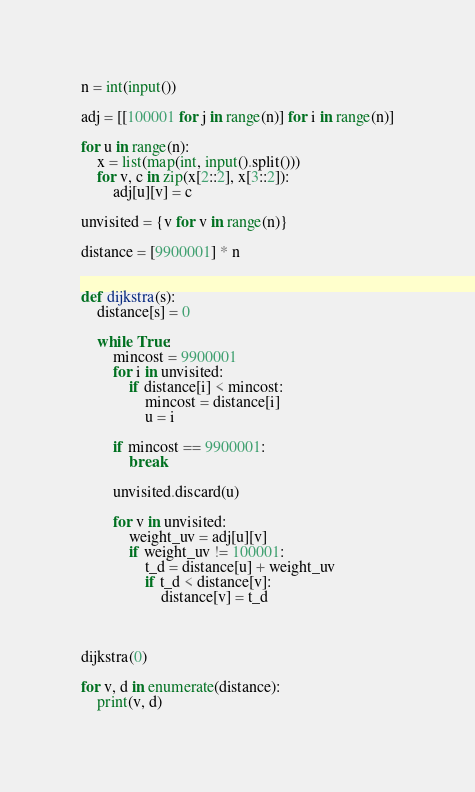Convert code to text. <code><loc_0><loc_0><loc_500><loc_500><_Python_>n = int(input())

adj = [[100001 for j in range(n)] for i in range(n)]

for u in range(n):
    x = list(map(int, input().split()))
    for v, c in zip(x[2::2], x[3::2]):
        adj[u][v] = c

unvisited = {v for v in range(n)}

distance = [9900001] * n


def dijkstra(s):
    distance[s] = 0

    while True:
        mincost = 9900001
        for i in unvisited:
            if distance[i] < mincost:
                mincost = distance[i]
                u = i

        if mincost == 9900001:
            break

        unvisited.discard(u)

        for v in unvisited:
            weight_uv = adj[u][v]
            if weight_uv != 100001:
                t_d = distance[u] + weight_uv
                if t_d < distance[v]:
                    distance[v] = t_d



dijkstra(0)

for v, d in enumerate(distance):
    print(v, d)</code> 